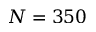Convert formula to latex. <formula><loc_0><loc_0><loc_500><loc_500>N = 3 5 0</formula> 